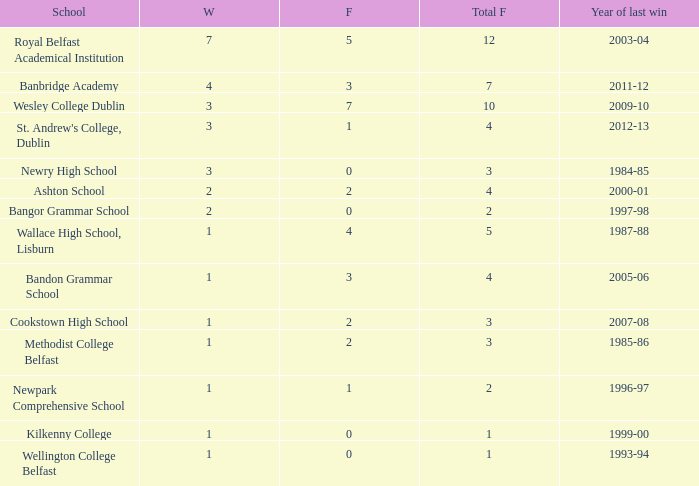In what year was the total finals at 10? 2009-10. 